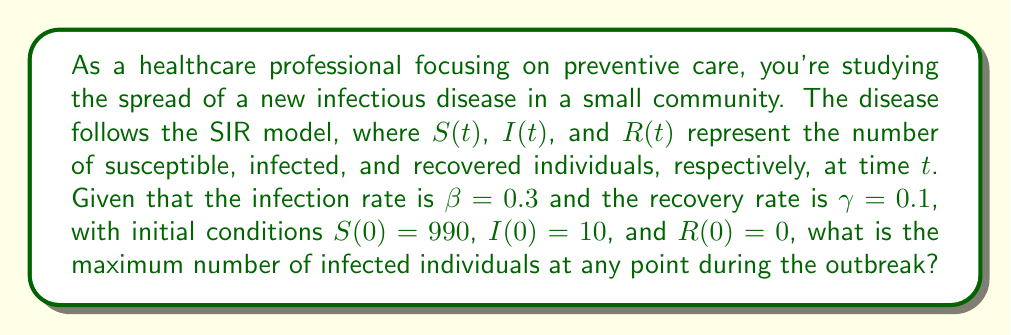Give your solution to this math problem. To solve this problem, we'll follow these steps:

1) The SIR model is described by the following system of differential equations:

   $$\frac{dS}{dt} = -\beta SI$$
   $$\frac{dI}{dt} = \beta SI - \gamma I$$
   $$\frac{dR}{dt} = \gamma I$$

2) The maximum number of infected individuals occurs when $\frac{dI}{dt} = 0$. At this point:

   $$\beta SI - \gamma I = 0$$
   $$\beta S - \gamma = 0$$
   $$S = \frac{\gamma}{\beta}$$

3) Substituting the given values:

   $$S = \frac{0.1}{0.3} = \frac{1}{3}$$

4) The total population $N$ is constant:

   $$N = S(0) + I(0) + R(0) = 990 + 10 + 0 = 1000$$

5) At the peak of infection:

   $$N = S + I + R$$
   $$1000 = \frac{1}{3} + I + R$$

6) We can find $R$ using the conservation of population principle:

   $$R = N - S - I = 1000 - \frac{1}{3} - I$$

7) Substituting this into the equation from step 5:

   $$1000 = \frac{1}{3} + I + (1000 - \frac{1}{3} - I)$$
   $$1000 = 1000 + \frac{1}{3} - \frac{1}{3}$$

8) This equation is true for any value of $I$, confirming our calculation of $S$ at the peak.

9) To find $I$ at its peak, we use:

   $$I = N - S - R = 1000 - \frac{1}{3} - R$$

10) We can find $R$ using the relation $\frac{dR}{dS} = -\frac{\gamma}{\beta S}$:

    $$R - R(0) = -\frac{\gamma}{\beta} \ln\frac{S}{S(0)}$$
    $$R = -\frac{0.1}{0.3} \ln\frac{\frac{1}{3}}{990} \approx 666.33$$

11) Therefore, at the peak:

    $$I = 1000 - \frac{1}{3} - 666.33 \approx 333.33$$

The maximum number of infected individuals is approximately 333.
Answer: 333 